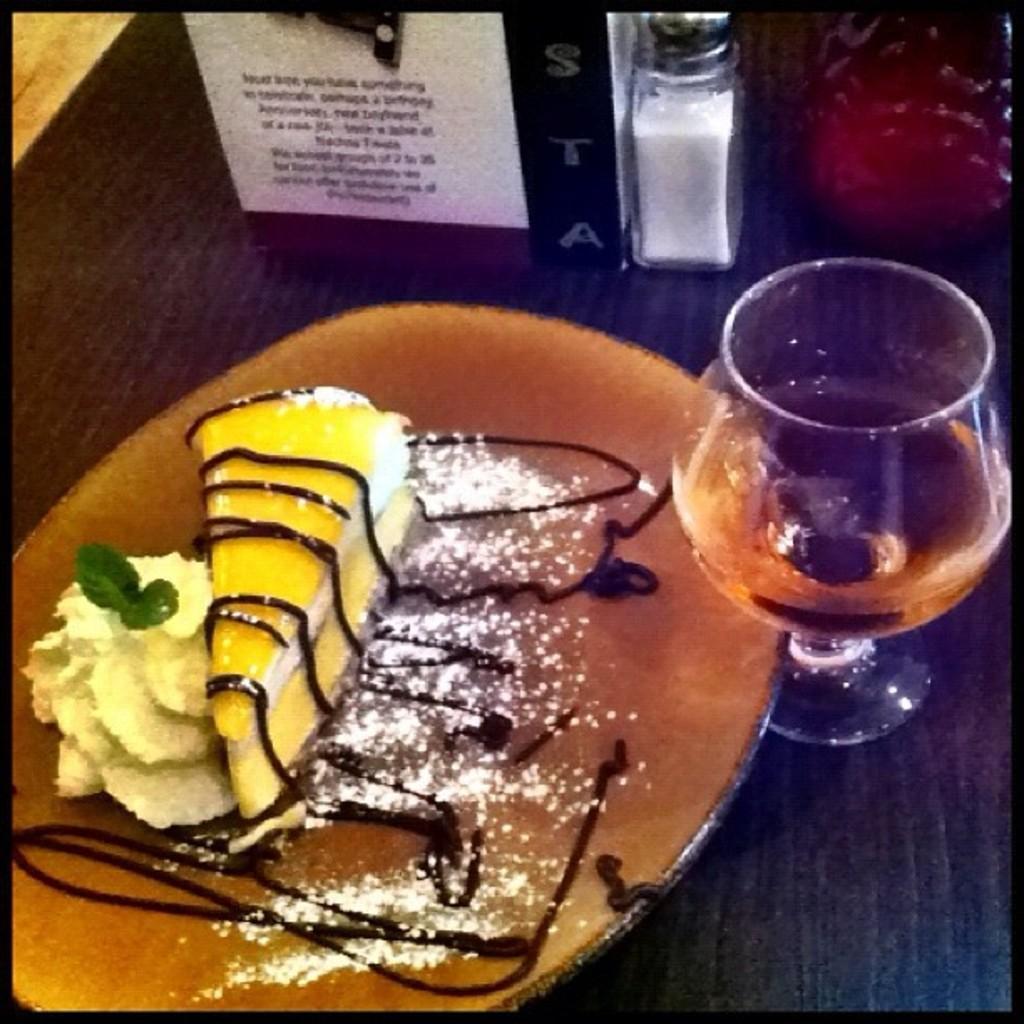In one or two sentences, can you explain what this image depicts? In this picture we can see food in the plate, beside to the plate we can find a glass on the right side of the image, and also we can see a bottle, paper and other things on the table. 